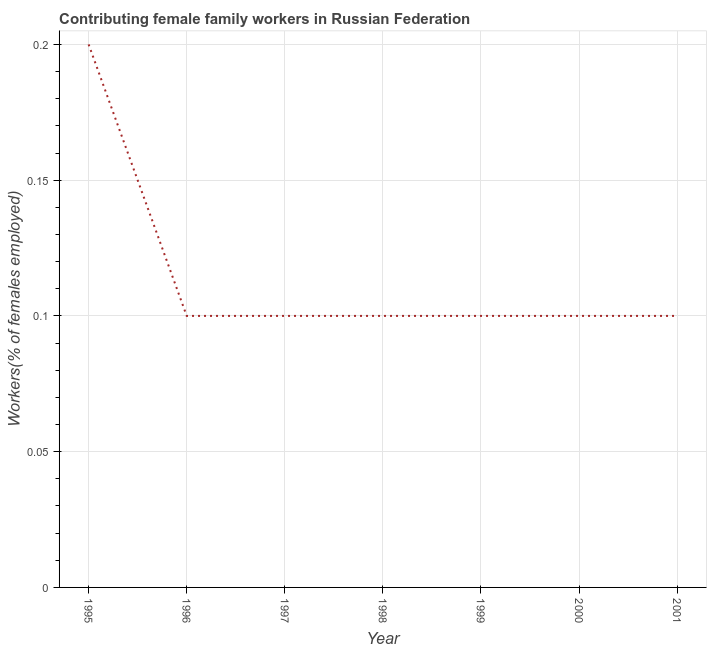What is the contributing female family workers in 1996?
Your answer should be compact. 0.1. Across all years, what is the maximum contributing female family workers?
Offer a very short reply. 0.2. Across all years, what is the minimum contributing female family workers?
Your answer should be compact. 0.1. In which year was the contributing female family workers maximum?
Your answer should be very brief. 1995. What is the sum of the contributing female family workers?
Make the answer very short. 0.8. What is the difference between the contributing female family workers in 1995 and 2000?
Your response must be concise. 0.1. What is the average contributing female family workers per year?
Ensure brevity in your answer.  0.11. What is the median contributing female family workers?
Provide a succinct answer. 0.1. In how many years, is the contributing female family workers greater than 0.16000000000000003 %?
Offer a terse response. 1. Do a majority of the years between 1996 and 1997 (inclusive) have contributing female family workers greater than 0.16000000000000003 %?
Provide a succinct answer. No. What is the ratio of the contributing female family workers in 1996 to that in 2000?
Make the answer very short. 1. Is the contributing female family workers in 2000 less than that in 2001?
Give a very brief answer. No. Is the difference between the contributing female family workers in 1996 and 2001 greater than the difference between any two years?
Offer a very short reply. No. What is the difference between the highest and the second highest contributing female family workers?
Ensure brevity in your answer.  0.1. What is the difference between the highest and the lowest contributing female family workers?
Your answer should be compact. 0.1. In how many years, is the contributing female family workers greater than the average contributing female family workers taken over all years?
Keep it short and to the point. 1. Does the contributing female family workers monotonically increase over the years?
Give a very brief answer. No. How many years are there in the graph?
Provide a short and direct response. 7. What is the difference between two consecutive major ticks on the Y-axis?
Provide a succinct answer. 0.05. Are the values on the major ticks of Y-axis written in scientific E-notation?
Make the answer very short. No. Does the graph contain any zero values?
Your answer should be very brief. No. Does the graph contain grids?
Offer a terse response. Yes. What is the title of the graph?
Ensure brevity in your answer.  Contributing female family workers in Russian Federation. What is the label or title of the X-axis?
Your answer should be very brief. Year. What is the label or title of the Y-axis?
Give a very brief answer. Workers(% of females employed). What is the Workers(% of females employed) of 1995?
Offer a terse response. 0.2. What is the Workers(% of females employed) in 1996?
Ensure brevity in your answer.  0.1. What is the Workers(% of females employed) of 1997?
Make the answer very short. 0.1. What is the Workers(% of females employed) of 1998?
Your answer should be very brief. 0.1. What is the Workers(% of females employed) in 1999?
Make the answer very short. 0.1. What is the Workers(% of females employed) in 2000?
Give a very brief answer. 0.1. What is the Workers(% of females employed) in 2001?
Keep it short and to the point. 0.1. What is the difference between the Workers(% of females employed) in 1995 and 1998?
Give a very brief answer. 0.1. What is the difference between the Workers(% of females employed) in 1995 and 1999?
Offer a terse response. 0.1. What is the difference between the Workers(% of females employed) in 1996 and 2001?
Offer a very short reply. 0. What is the difference between the Workers(% of females employed) in 1997 and 1998?
Provide a succinct answer. 0. What is the difference between the Workers(% of females employed) in 1997 and 2001?
Make the answer very short. 0. What is the difference between the Workers(% of females employed) in 1998 and 1999?
Provide a succinct answer. 0. What is the difference between the Workers(% of females employed) in 1998 and 2000?
Your response must be concise. 0. What is the difference between the Workers(% of females employed) in 1998 and 2001?
Provide a short and direct response. 0. What is the difference between the Workers(% of females employed) in 1999 and 2000?
Provide a succinct answer. 0. What is the difference between the Workers(% of females employed) in 1999 and 2001?
Provide a succinct answer. 0. What is the difference between the Workers(% of females employed) in 2000 and 2001?
Offer a terse response. 0. What is the ratio of the Workers(% of females employed) in 1995 to that in 1997?
Offer a terse response. 2. What is the ratio of the Workers(% of females employed) in 1995 to that in 2001?
Give a very brief answer. 2. What is the ratio of the Workers(% of females employed) in 1996 to that in 1997?
Offer a terse response. 1. What is the ratio of the Workers(% of females employed) in 1996 to that in 1998?
Make the answer very short. 1. What is the ratio of the Workers(% of females employed) in 1996 to that in 2000?
Provide a succinct answer. 1. What is the ratio of the Workers(% of females employed) in 1997 to that in 2001?
Offer a very short reply. 1. What is the ratio of the Workers(% of females employed) in 1998 to that in 1999?
Offer a very short reply. 1. What is the ratio of the Workers(% of females employed) in 1999 to that in 2000?
Provide a succinct answer. 1. 